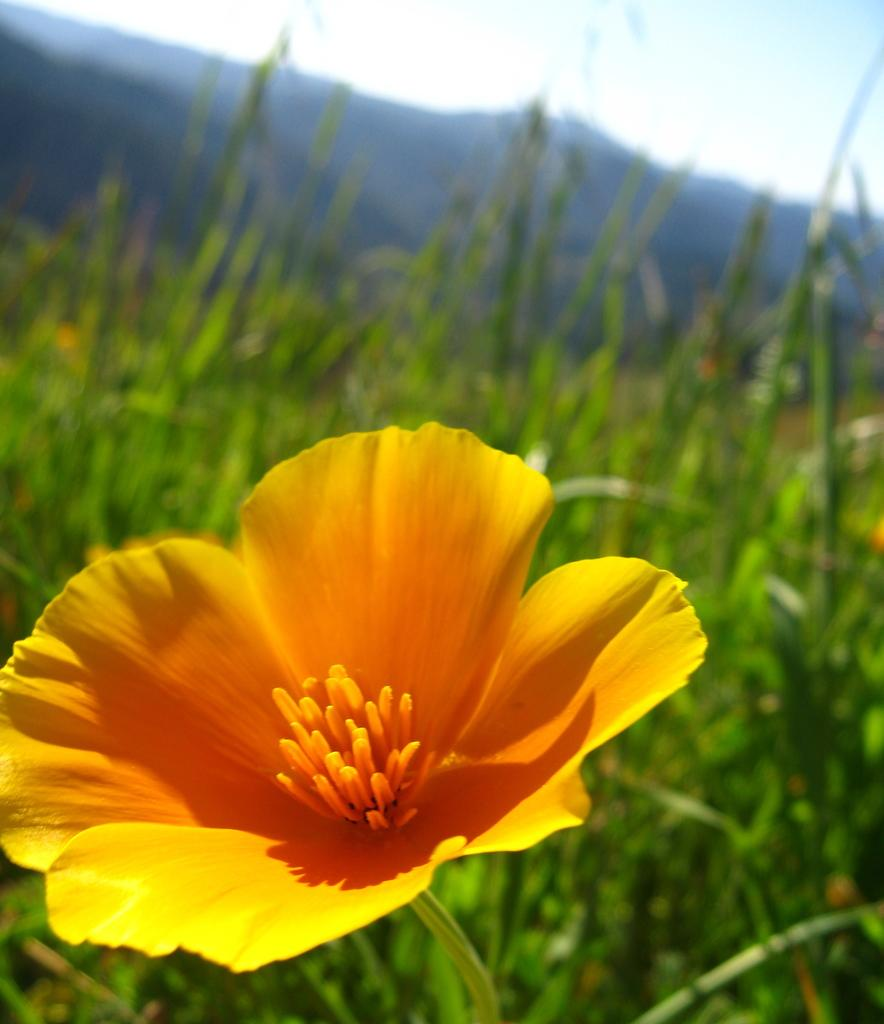What type of flower is present in the image? There is a yellow flower in the image. What else can be seen in the background of the image? There are plants and a hill visible in the background of the image. What is visible at the top of the image? The sky is visible at the top of the image. What type of rice is being harvested in the image? There is no rice present in the image; it features a yellow flower and a background with plants and a hill. How does the destruction of the hill affect the flower in the image? There is no destruction present in the image, and the hill is not affecting the flower in any way. 